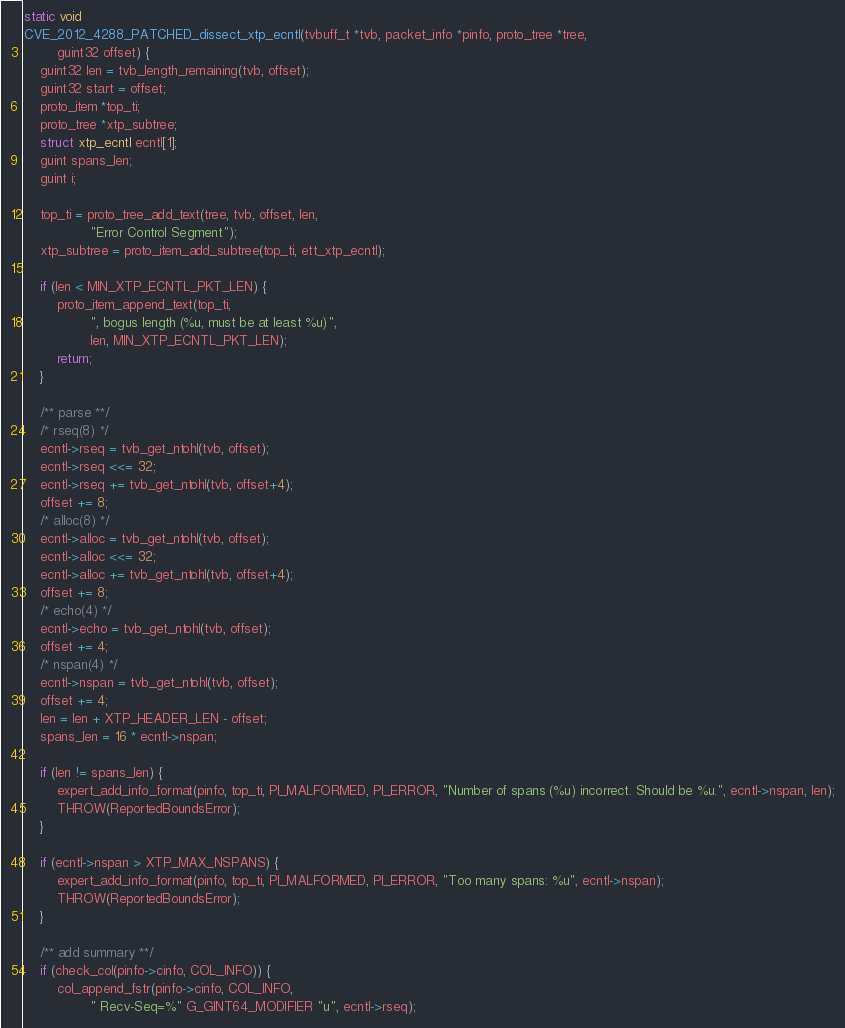<code> <loc_0><loc_0><loc_500><loc_500><_C_>static void
CVE_2012_4288_PATCHED_dissect_xtp_ecntl(tvbuff_t *tvb, packet_info *pinfo, proto_tree *tree,
		guint32 offset) {
	guint32 len = tvb_length_remaining(tvb, offset);
	guint32 start = offset;
	proto_item *top_ti;
	proto_tree *xtp_subtree;
	struct xtp_ecntl ecntl[1];
	guint spans_len;
	guint i;

	top_ti = proto_tree_add_text(tree, tvb, offset, len,
				"Error Control Segment");
	xtp_subtree = proto_item_add_subtree(top_ti, ett_xtp_ecntl);

	if (len < MIN_XTP_ECNTL_PKT_LEN) {
		proto_item_append_text(top_ti,
				", bogus length (%u, must be at least %u)",
				len, MIN_XTP_ECNTL_PKT_LEN);
		return;
	}

	/** parse **/
	/* rseq(8) */
	ecntl->rseq = tvb_get_ntohl(tvb, offset);
	ecntl->rseq <<= 32;
	ecntl->rseq += tvb_get_ntohl(tvb, offset+4);
	offset += 8;
	/* alloc(8) */
	ecntl->alloc = tvb_get_ntohl(tvb, offset);
	ecntl->alloc <<= 32;
	ecntl->alloc += tvb_get_ntohl(tvb, offset+4);
	offset += 8;
	/* echo(4) */
	ecntl->echo = tvb_get_ntohl(tvb, offset);
	offset += 4;
	/* nspan(4) */
	ecntl->nspan = tvb_get_ntohl(tvb, offset);
	offset += 4;
	len = len + XTP_HEADER_LEN - offset;
	spans_len = 16 * ecntl->nspan;

	if (len != spans_len) {
		expert_add_info_format(pinfo, top_ti, PI_MALFORMED, PI_ERROR, "Number of spans (%u) incorrect. Should be %u.", ecntl->nspan, len);
		THROW(ReportedBoundsError);
	}

	if (ecntl->nspan > XTP_MAX_NSPANS) {
		expert_add_info_format(pinfo, top_ti, PI_MALFORMED, PI_ERROR, "Too many spans: %u", ecntl->nspan);
		THROW(ReportedBoundsError);
	}

	/** add summary **/
	if (check_col(pinfo->cinfo, COL_INFO)) {
		col_append_fstr(pinfo->cinfo, COL_INFO,
				" Recv-Seq=%" G_GINT64_MODIFIER "u", ecntl->rseq);</code> 